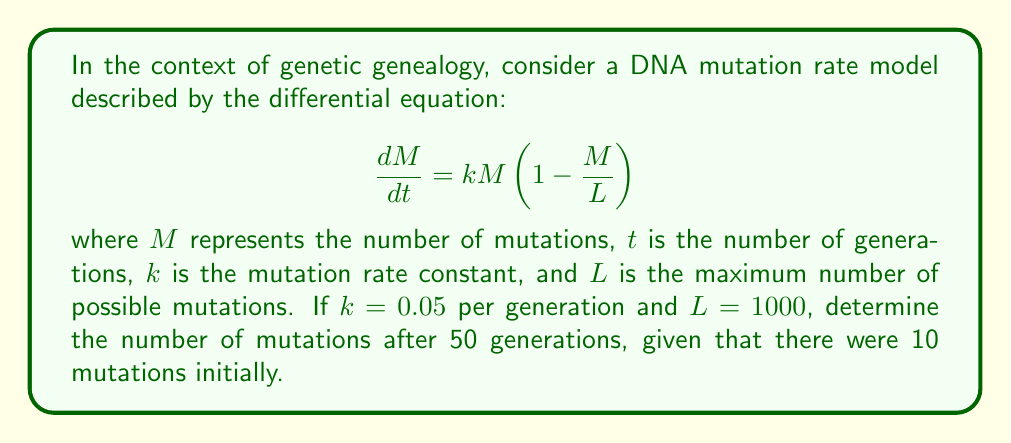Can you solve this math problem? To solve this problem, we need to use the logistic differential equation, which is commonly used in population growth models and can be applied to DNA mutation accumulation over generations.

1. First, we recognize the given equation as a logistic differential equation:
   $$\frac{dM}{dt} = kM(1 - \frac{M}{L})$$

2. The solution to this equation is given by:
   $$M(t) = \frac{L}{1 + (\frac{L}{M_0} - 1)e^{-kt}}$$
   where $M_0$ is the initial number of mutations.

3. We are given the following values:
   $k = 0.05$ per generation
   $L = 1000$ mutations
   $M_0 = 10$ mutations
   $t = 50$ generations

4. Substituting these values into the solution:
   $$M(50) = \frac{1000}{1 + (\frac{1000}{10} - 1)e^{-0.05 \cdot 50}}$$

5. Simplify:
   $$M(50) = \frac{1000}{1 + 99e^{-2.5}}$$

6. Calculate $e^{-2.5} \approx 0.0821$:
   $$M(50) = \frac{1000}{1 + 99 \cdot 0.0821} \approx \frac{1000}{9.1279}$$

7. Evaluate the final result:
   $$M(50) \approx 109.55$$

8. Since we're dealing with discrete mutations, we round to the nearest whole number:
   $$M(50) \approx 110$$ mutations
Answer: After 50 generations, the number of mutations is approximately 110. 